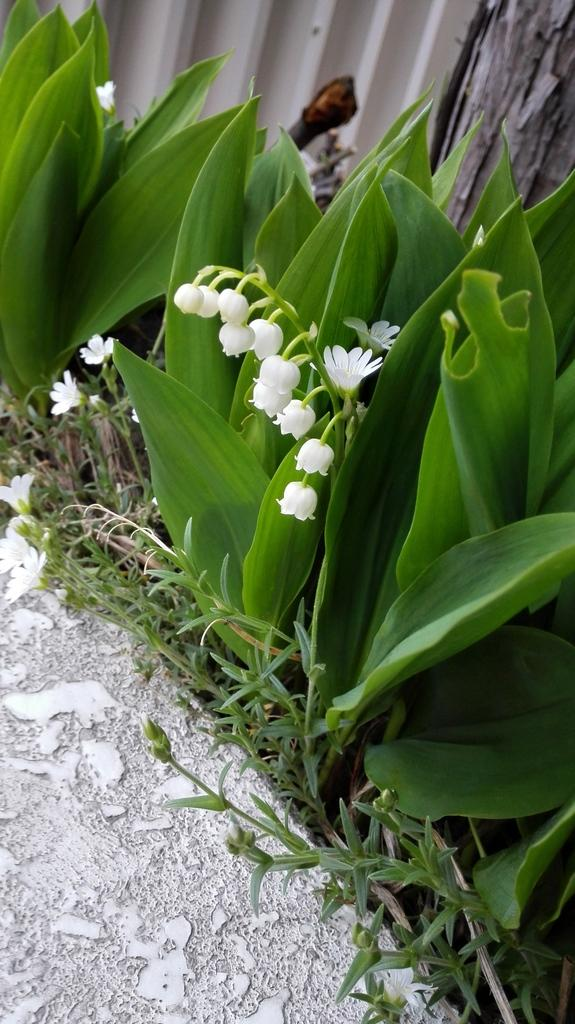What is the main subject in the middle of the picture? There are white color flowers in the middle of the picture. What else can be seen in the picture besides the flowers? There are plants in the picture. Where are flower petals located on the left side of the image? Flower petals are present on the land on the left side of the image. How many rabbits can be seen playing with a cactus in the image? There are no rabbits or cactus present in the image; it features white color flowers and other plants. Can you tell me the color of the hen in the image? There is no hen present in the image. 